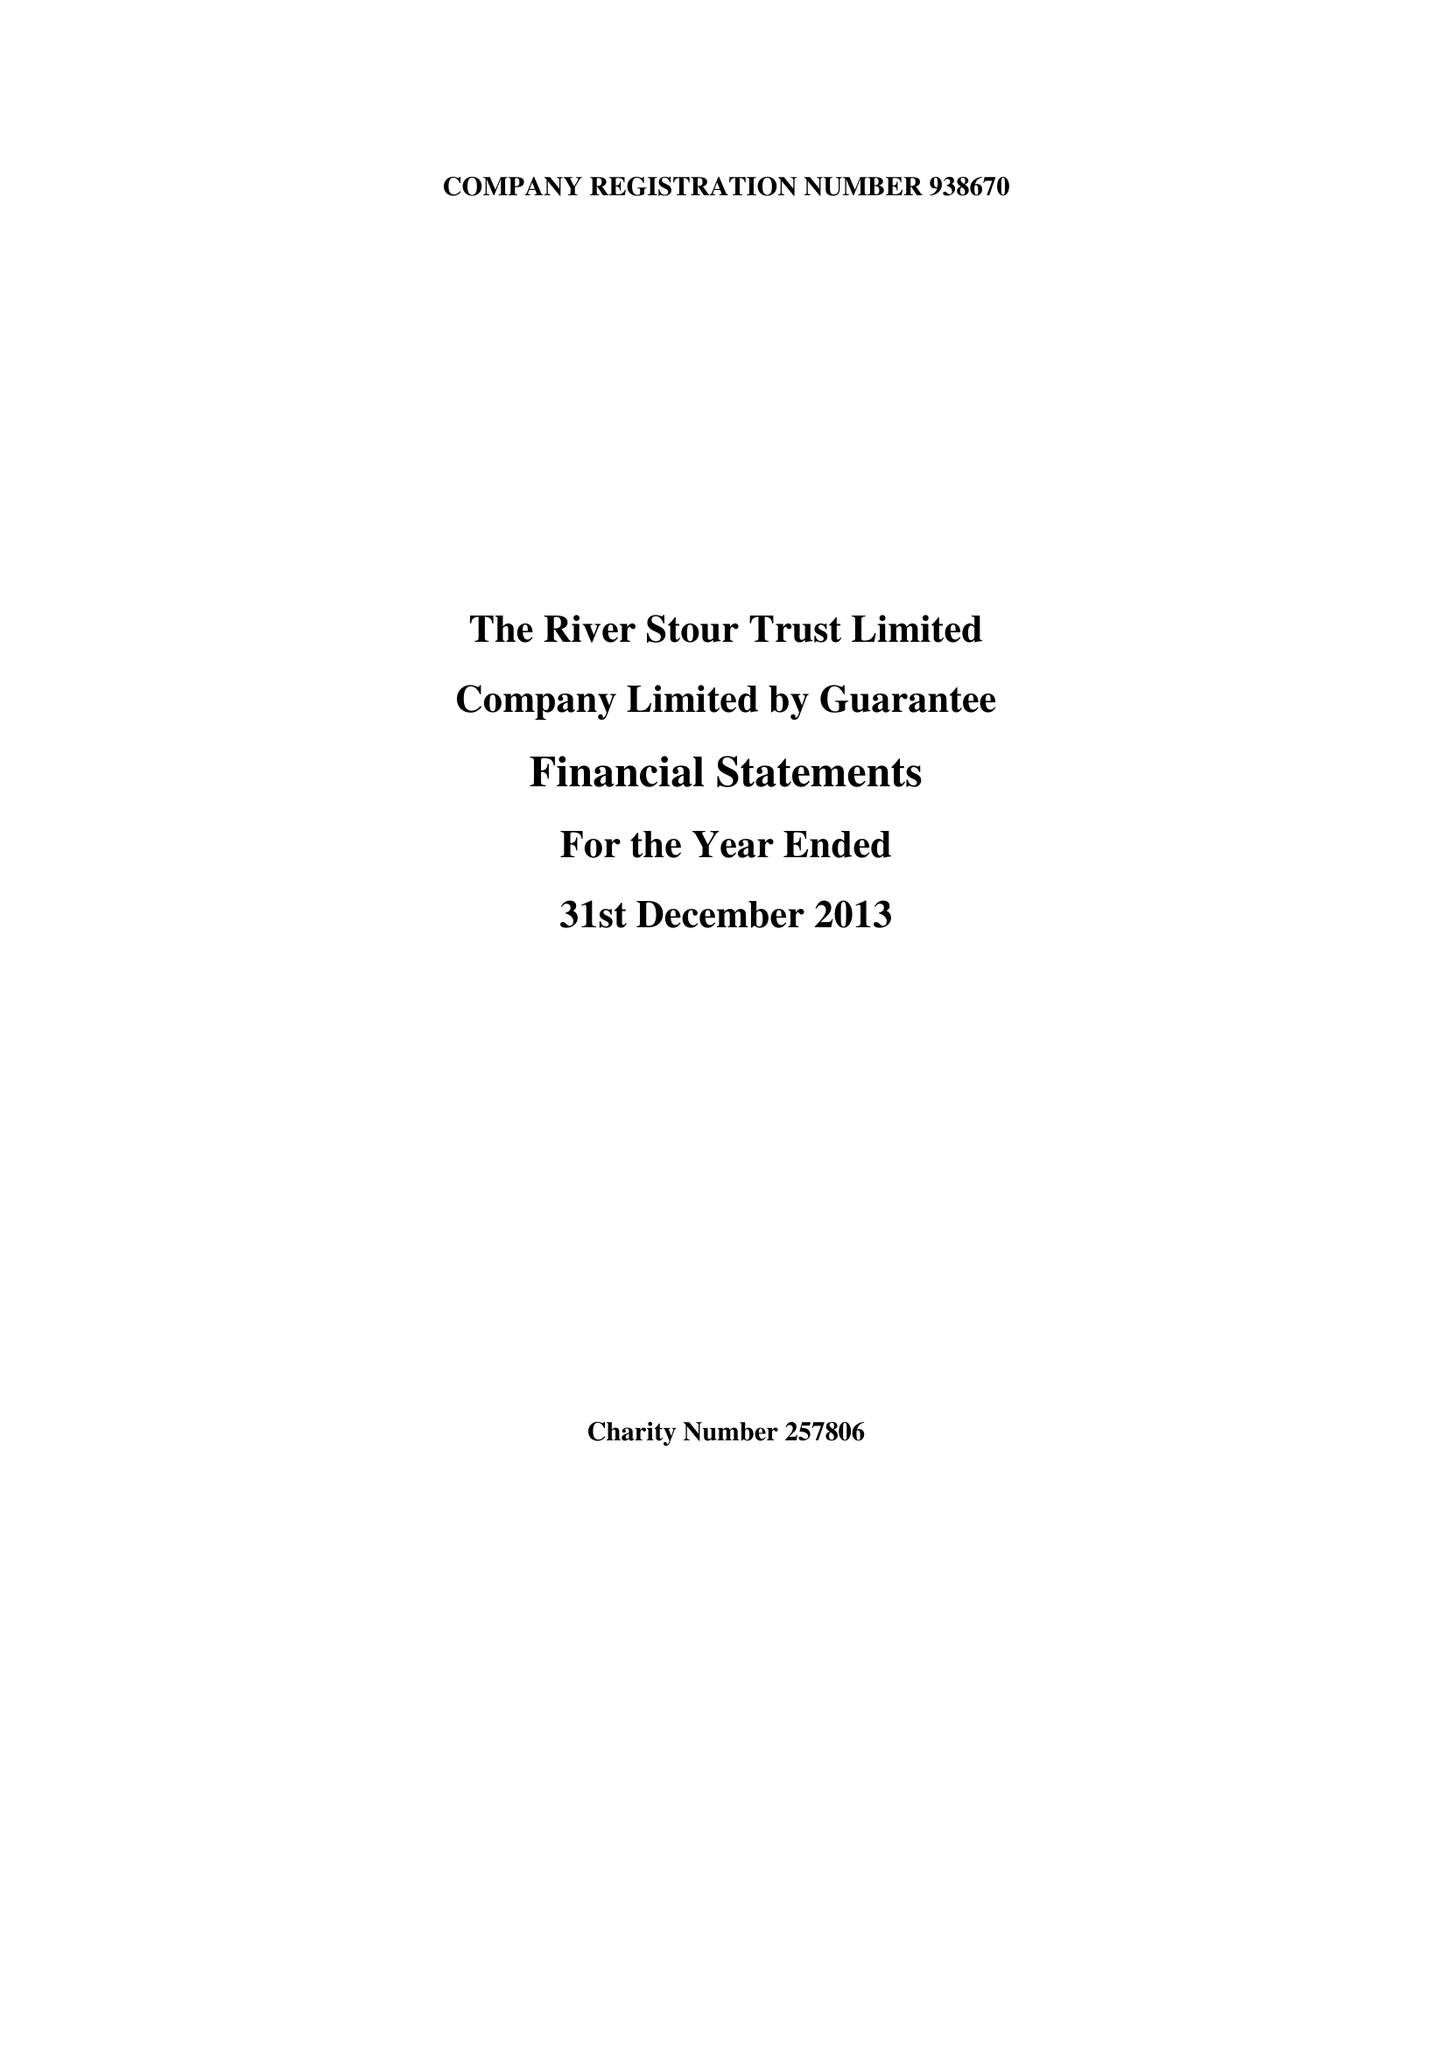What is the value for the charity_number?
Answer the question using a single word or phrase. 257806 